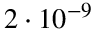Convert formula to latex. <formula><loc_0><loc_0><loc_500><loc_500>2 \cdot 1 0 ^ { - 9 }</formula> 